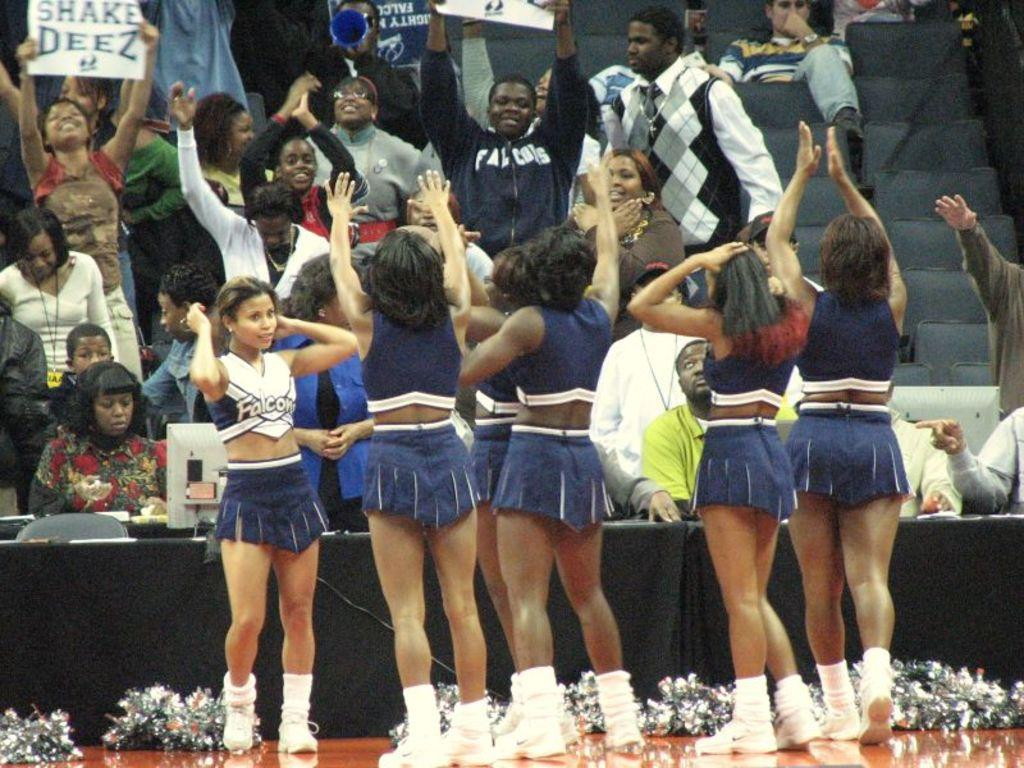<image>
Write a terse but informative summary of the picture. cheerleaders wearing uniforms that say 'Falcons' on them 